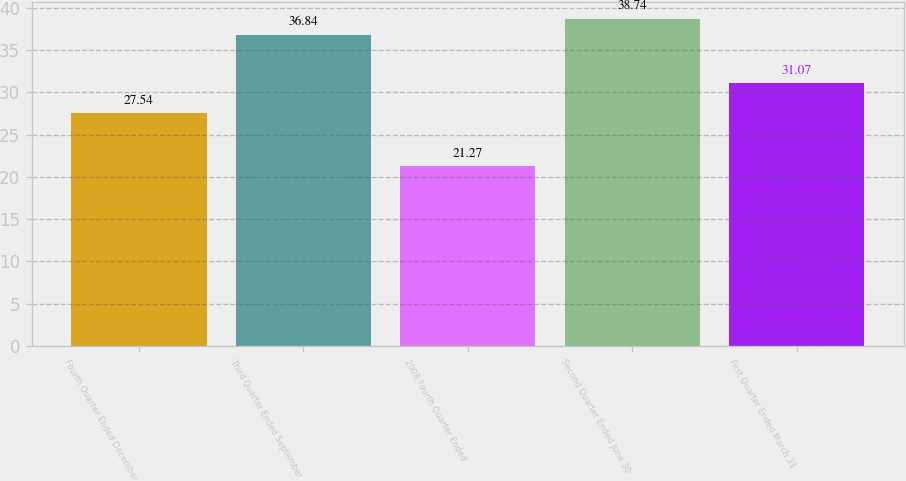Convert chart to OTSL. <chart><loc_0><loc_0><loc_500><loc_500><bar_chart><fcel>Fourth Quarter Ended December<fcel>Third Quarter Ended September<fcel>2008 Fourth Quarter Ended<fcel>Second Quarter Ended June 30<fcel>First Quarter Ended March 31<nl><fcel>27.54<fcel>36.84<fcel>21.27<fcel>38.74<fcel>31.07<nl></chart> 